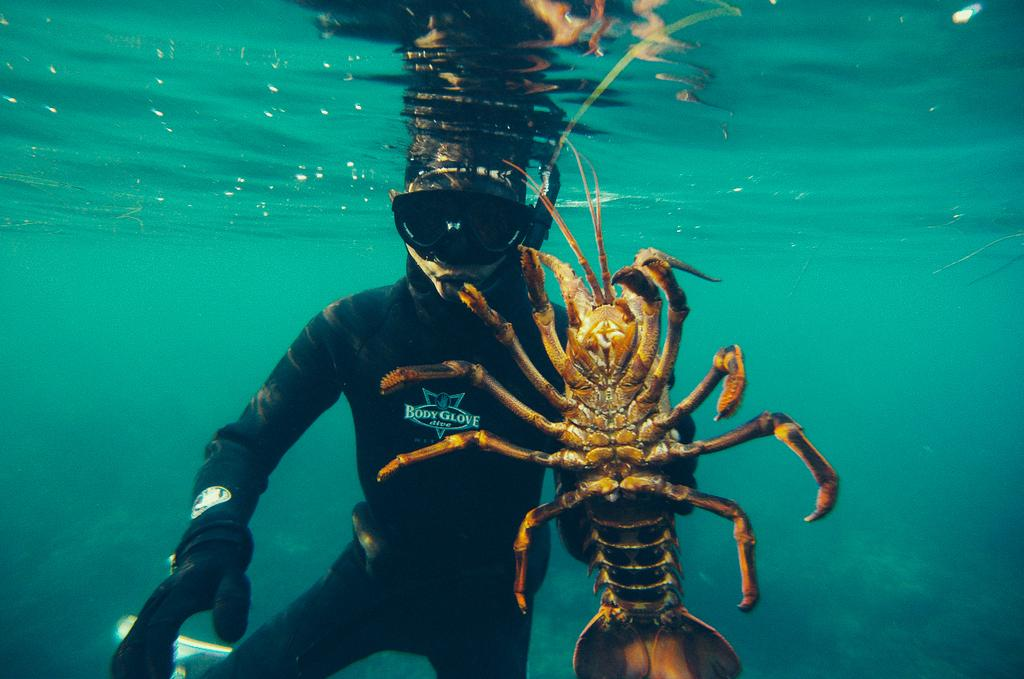What is present in the image that is not a solid object? There is water in the image. Can you describe the person in the water? The person in the water is wearing a black jacket. What else can be seen in the water besides the person? There is an insect in the water. How many needles can be seen floating in the water? There are no needles present in the image; it only features a person, a black jacket, and an insect in the water. What type of frogs are visible in the water? There are no frogs present in the image; it only features a person, a black jacket, and an insect in the water. 